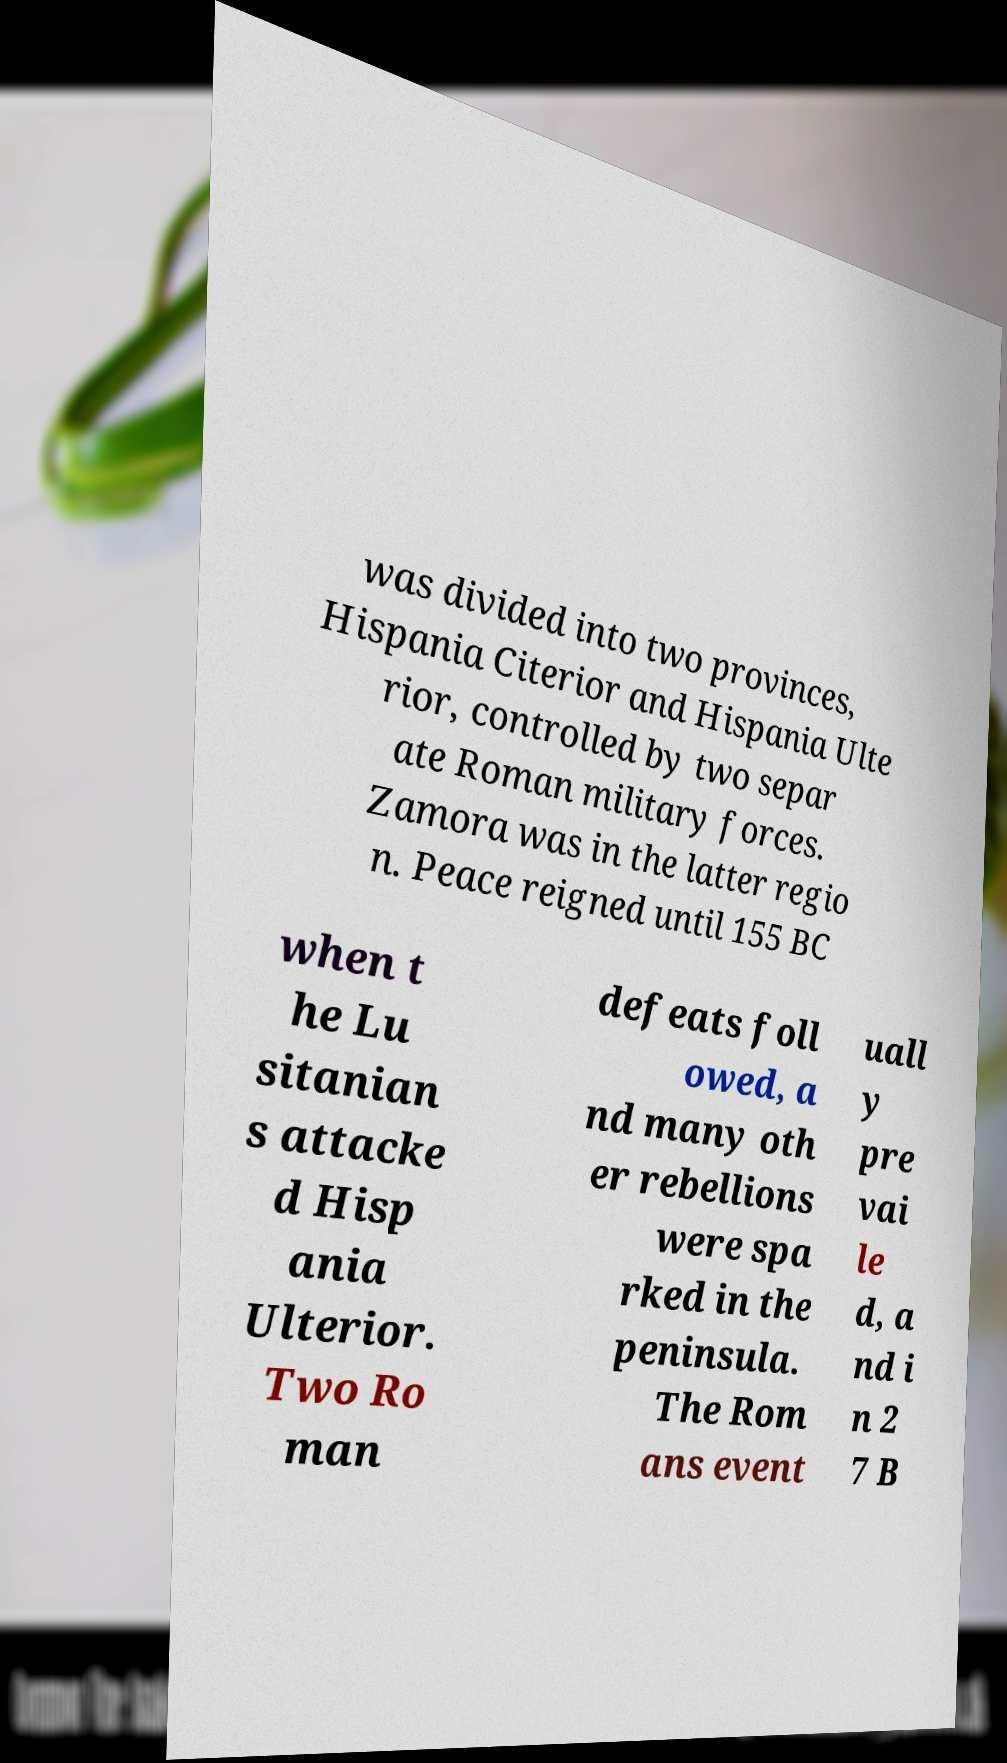For documentation purposes, I need the text within this image transcribed. Could you provide that? was divided into two provinces, Hispania Citerior and Hispania Ulte rior, controlled by two separ ate Roman military forces. Zamora was in the latter regio n. Peace reigned until 155 BC when t he Lu sitanian s attacke d Hisp ania Ulterior. Two Ro man defeats foll owed, a nd many oth er rebellions were spa rked in the peninsula. The Rom ans event uall y pre vai le d, a nd i n 2 7 B 